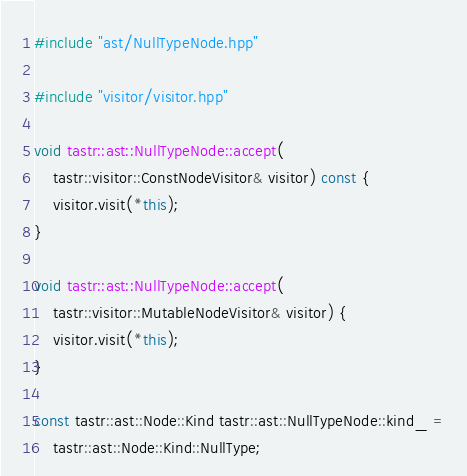<code> <loc_0><loc_0><loc_500><loc_500><_C++_>#include "ast/NullTypeNode.hpp"

#include "visitor/visitor.hpp"

void tastr::ast::NullTypeNode::accept(
    tastr::visitor::ConstNodeVisitor& visitor) const {
    visitor.visit(*this);
}

void tastr::ast::NullTypeNode::accept(
    tastr::visitor::MutableNodeVisitor& visitor) {
    visitor.visit(*this);
}

const tastr::ast::Node::Kind tastr::ast::NullTypeNode::kind_ =
    tastr::ast::Node::Kind::NullType;
</code> 